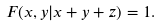Convert formula to latex. <formula><loc_0><loc_0><loc_500><loc_500>F ( x , y | x + y + z ) = 1 .</formula> 